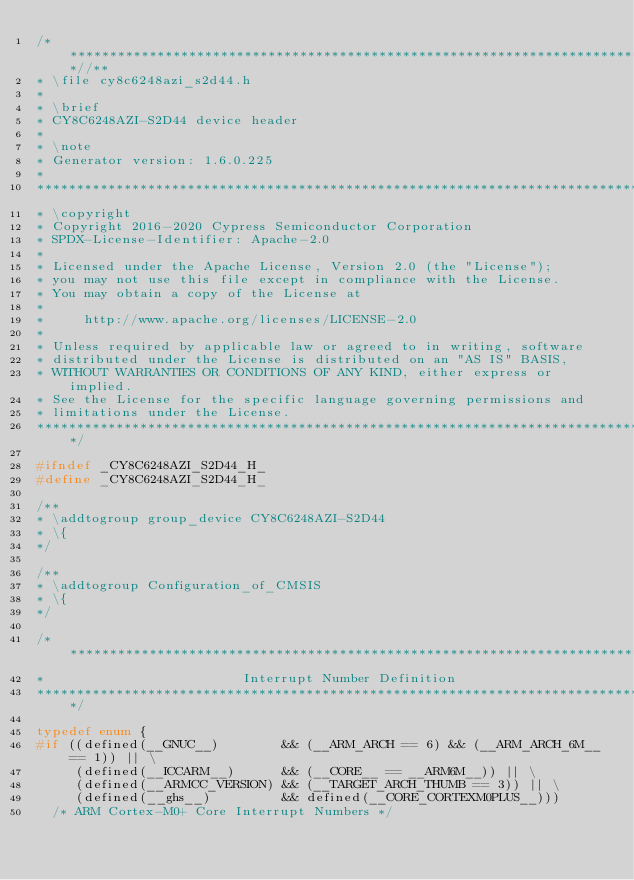Convert code to text. <code><loc_0><loc_0><loc_500><loc_500><_C_>/***************************************************************************//**
* \file cy8c6248azi_s2d44.h
*
* \brief
* CY8C6248AZI-S2D44 device header
*
* \note
* Generator version: 1.6.0.225
*
********************************************************************************
* \copyright
* Copyright 2016-2020 Cypress Semiconductor Corporation
* SPDX-License-Identifier: Apache-2.0
*
* Licensed under the Apache License, Version 2.0 (the "License");
* you may not use this file except in compliance with the License.
* You may obtain a copy of the License at
*
*     http://www.apache.org/licenses/LICENSE-2.0
*
* Unless required by applicable law or agreed to in writing, software
* distributed under the License is distributed on an "AS IS" BASIS,
* WITHOUT WARRANTIES OR CONDITIONS OF ANY KIND, either express or implied.
* See the License for the specific language governing permissions and
* limitations under the License.
*******************************************************************************/

#ifndef _CY8C6248AZI_S2D44_H_
#define _CY8C6248AZI_S2D44_H_

/**
* \addtogroup group_device CY8C6248AZI-S2D44
* \{
*/

/**
* \addtogroup Configuration_of_CMSIS
* \{
*/

/*******************************************************************************
*                         Interrupt Number Definition
*******************************************************************************/

typedef enum {
#if ((defined(__GNUC__)        && (__ARM_ARCH == 6) && (__ARM_ARCH_6M__ == 1)) || \
     (defined(__ICCARM__)      && (__CORE__ == __ARM6M__)) || \
     (defined(__ARMCC_VERSION) && (__TARGET_ARCH_THUMB == 3)) || \
     (defined(__ghs__)         && defined(__CORE_CORTEXM0PLUS__)))
  /* ARM Cortex-M0+ Core Interrupt Numbers */</code> 